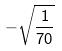<formula> <loc_0><loc_0><loc_500><loc_500>- \sqrt { \frac { 1 } { 7 0 } }</formula> 